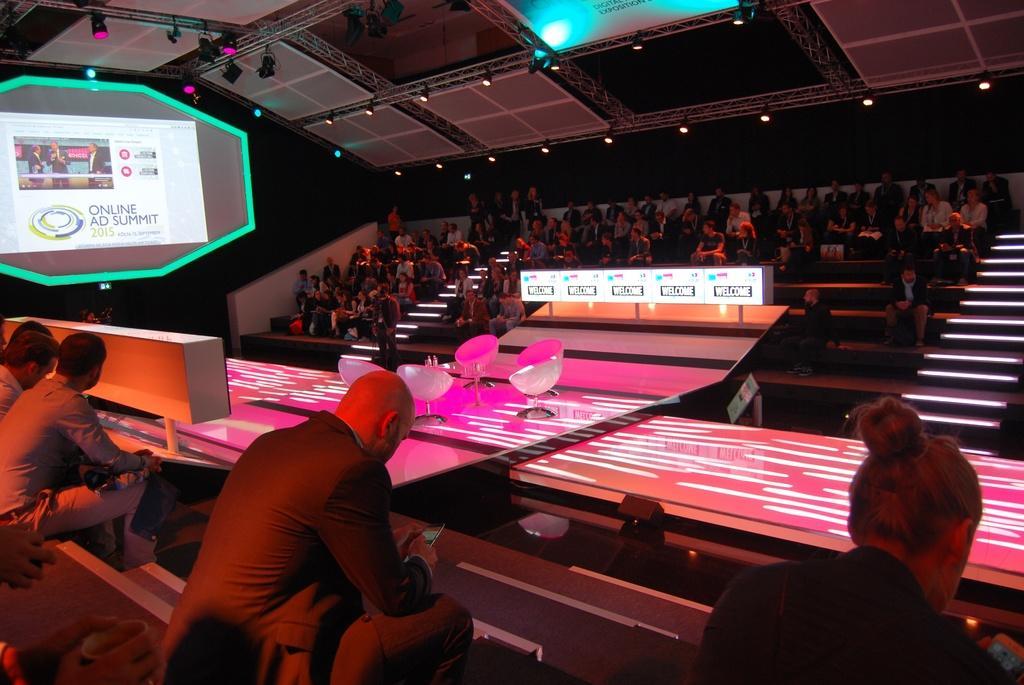Please provide a concise description of this image. In the picture we can see some people are sitting on the chairs and before to them, we can see some people are sitting near the desks and on the desk, we can see a pink color light with some white lines on it and to the ceiling we can see some screen and a light. 